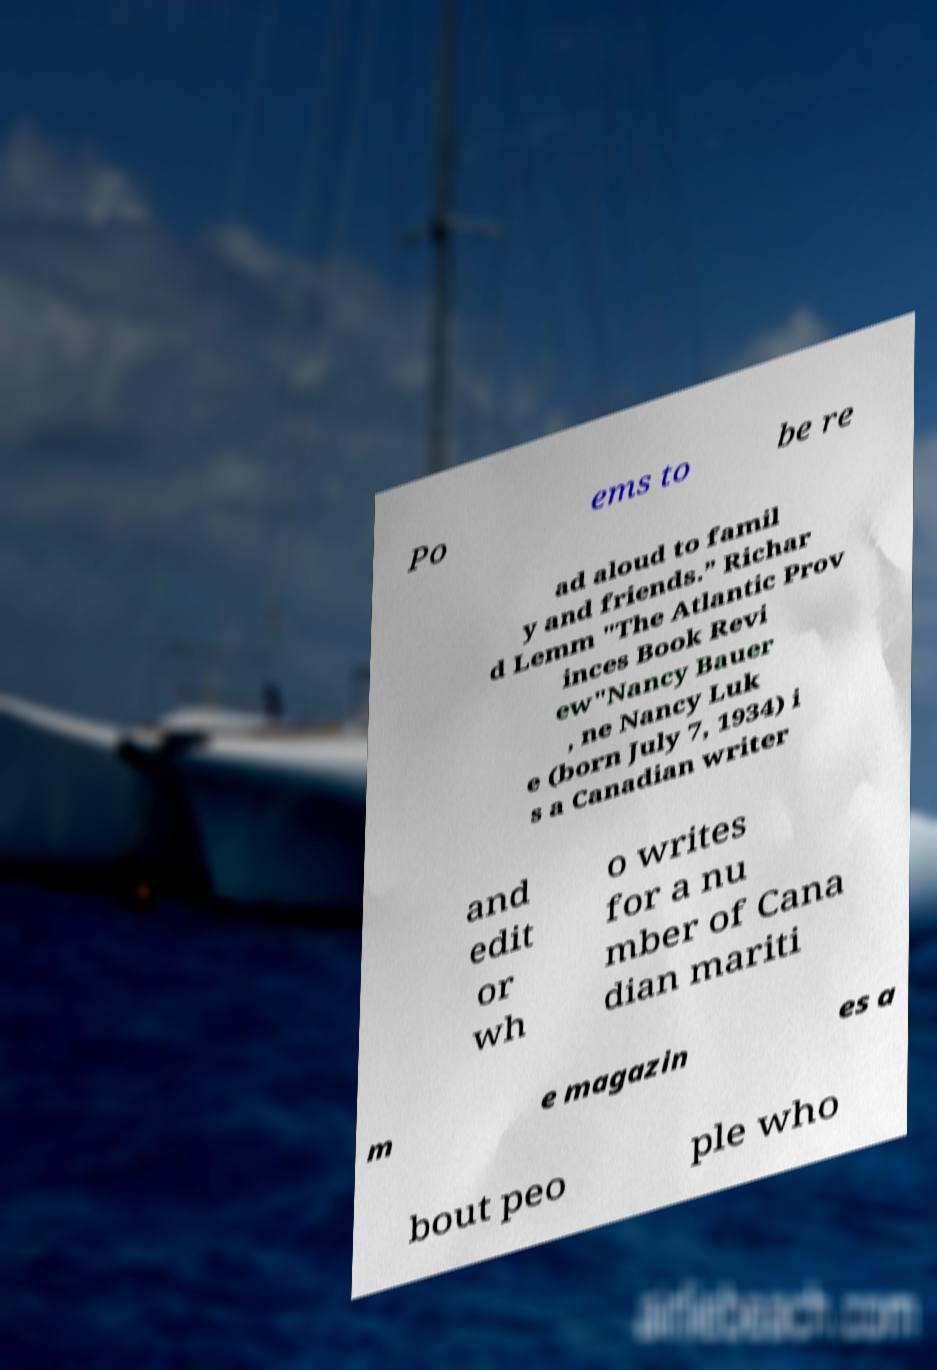What messages or text are displayed in this image? I need them in a readable, typed format. Po ems to be re ad aloud to famil y and friends.” Richar d Lemm "The Atlantic Prov inces Book Revi ew"Nancy Bauer , ne Nancy Luk e (born July 7, 1934) i s a Canadian writer and edit or wh o writes for a nu mber of Cana dian mariti m e magazin es a bout peo ple who 